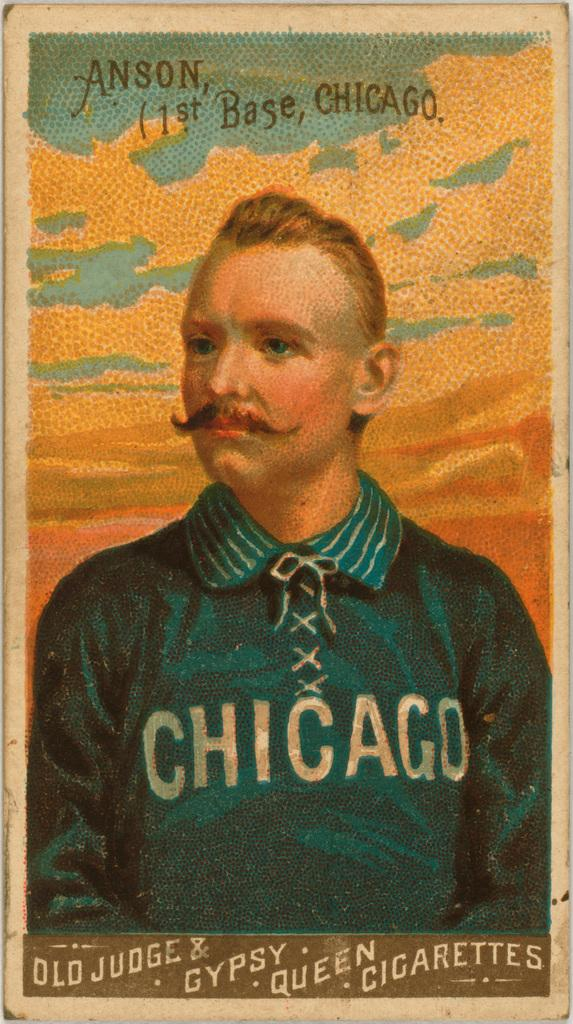<image>
Offer a succinct explanation of the picture presented. vintage baseball card showing picture of anson, who played first base for chicago 